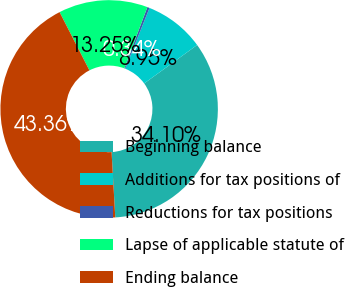Convert chart. <chart><loc_0><loc_0><loc_500><loc_500><pie_chart><fcel>Beginning balance<fcel>Additions for tax positions of<fcel>Reductions for tax positions<fcel>Lapse of applicable statute of<fcel>Ending balance<nl><fcel>34.1%<fcel>8.95%<fcel>0.34%<fcel>13.25%<fcel>43.36%<nl></chart> 